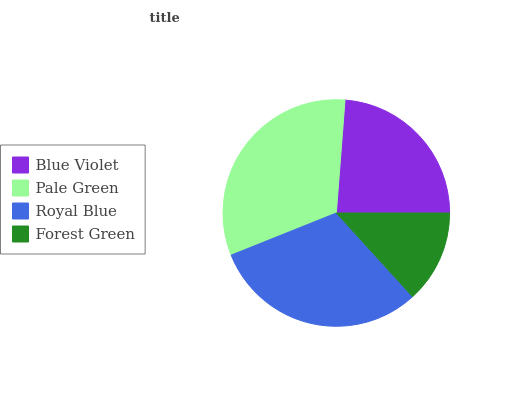Is Forest Green the minimum?
Answer yes or no. Yes. Is Pale Green the maximum?
Answer yes or no. Yes. Is Royal Blue the minimum?
Answer yes or no. No. Is Royal Blue the maximum?
Answer yes or no. No. Is Pale Green greater than Royal Blue?
Answer yes or no. Yes. Is Royal Blue less than Pale Green?
Answer yes or no. Yes. Is Royal Blue greater than Pale Green?
Answer yes or no. No. Is Pale Green less than Royal Blue?
Answer yes or no. No. Is Royal Blue the high median?
Answer yes or no. Yes. Is Blue Violet the low median?
Answer yes or no. Yes. Is Forest Green the high median?
Answer yes or no. No. Is Forest Green the low median?
Answer yes or no. No. 